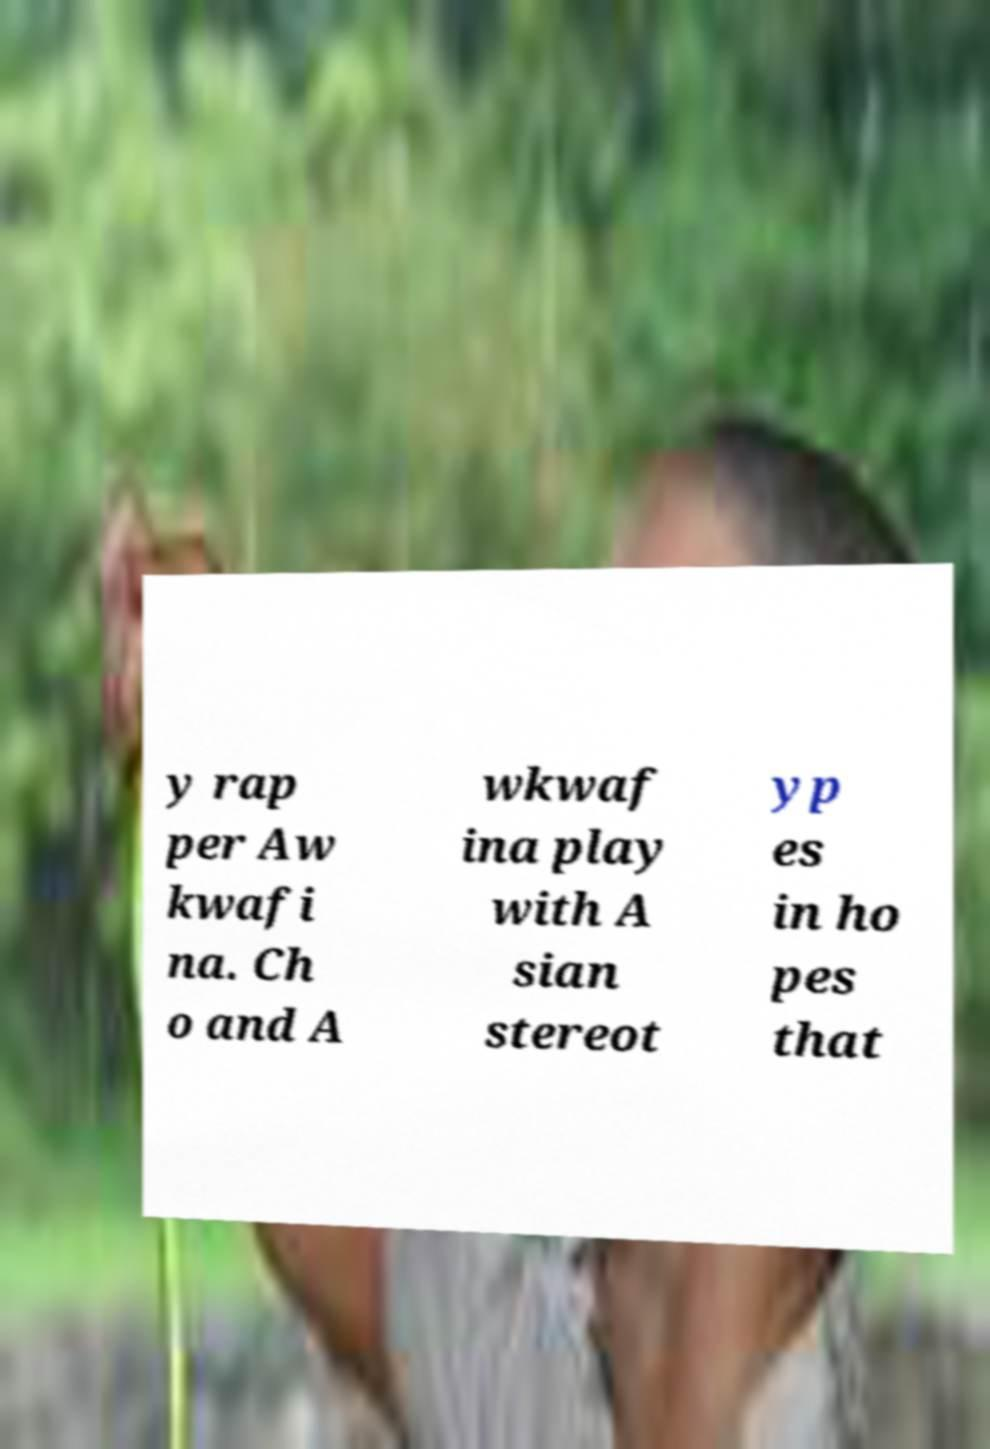Can you read and provide the text displayed in the image?This photo seems to have some interesting text. Can you extract and type it out for me? y rap per Aw kwafi na. Ch o and A wkwaf ina play with A sian stereot yp es in ho pes that 